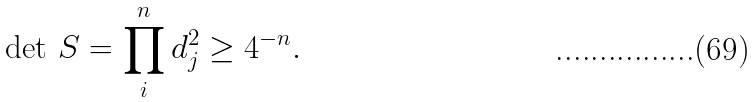<formula> <loc_0><loc_0><loc_500><loc_500>\det \, S = \prod _ { i } ^ { n } d _ { j } ^ { 2 } \geq 4 ^ { - n } .</formula> 